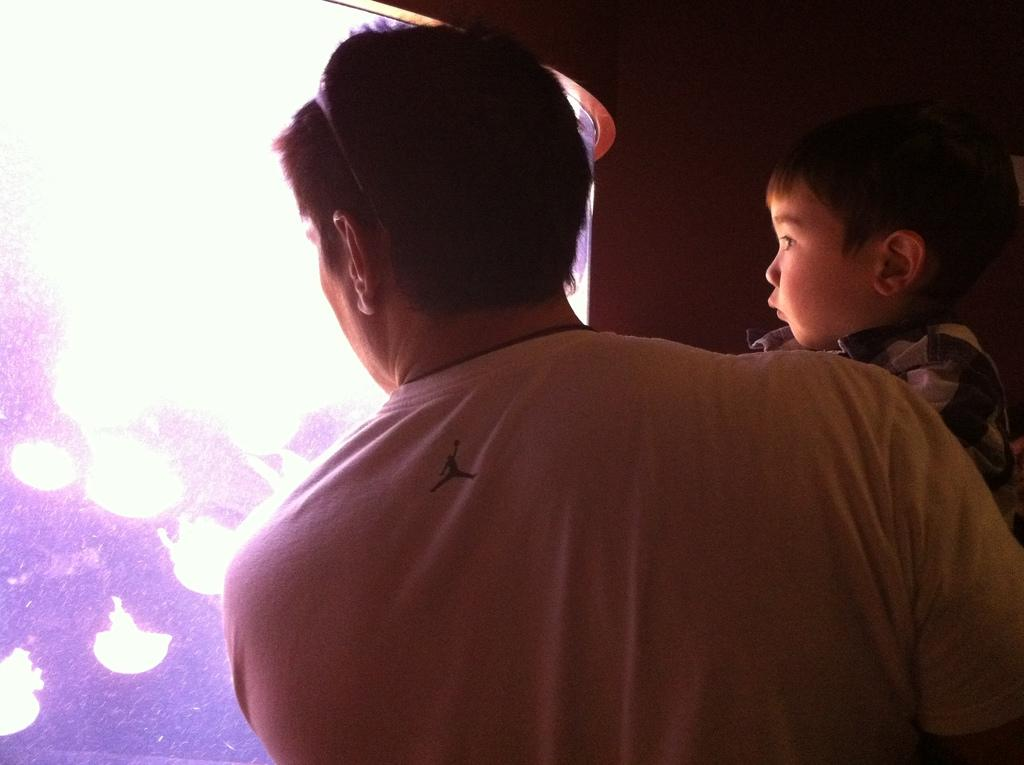Who is the main subject in the image? There is a man in the image. What is the man doing in the image? The man is holding a boy in his arms. What can be seen in front of the man and the boy? There appears to be an aquarium in front of them. How many fingers does the goldfish have in the image? There is no goldfish present in the image, so it is not possible to determine how many fingers it might have. 